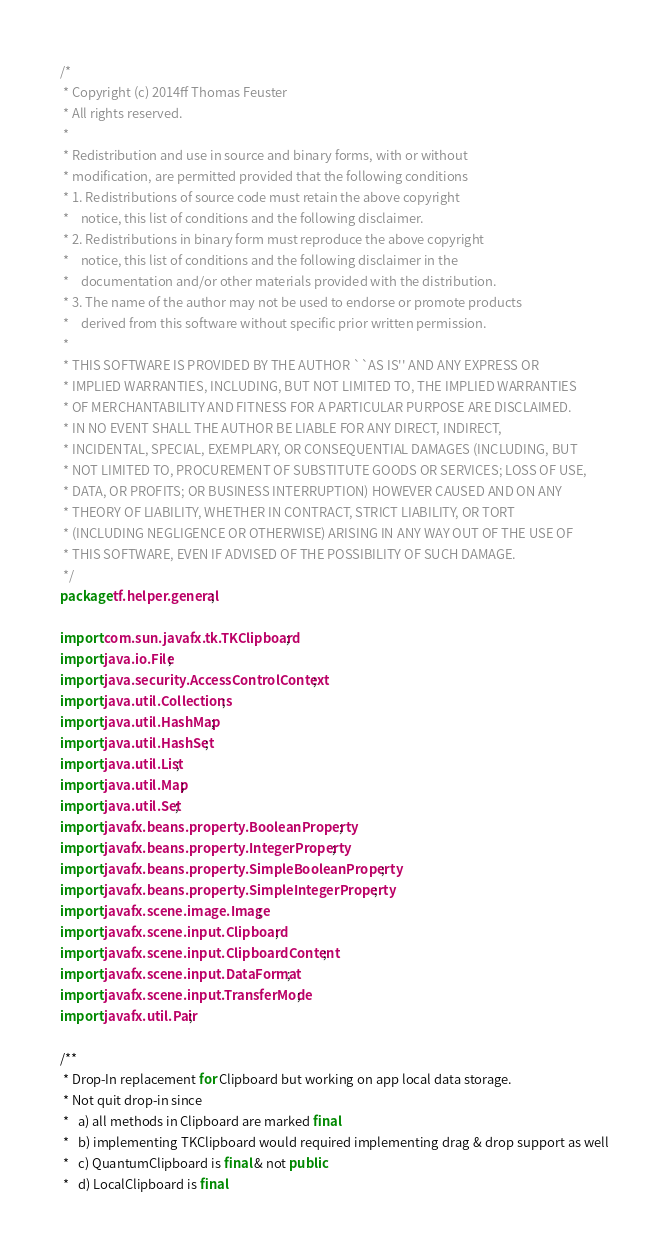Convert code to text. <code><loc_0><loc_0><loc_500><loc_500><_Java_>/*
 * Copyright (c) 2014ff Thomas Feuster
 * All rights reserved.
 * 
 * Redistribution and use in source and binary forms, with or without
 * modification, are permitted provided that the following conditions
 * 1. Redistributions of source code must retain the above copyright
 *    notice, this list of conditions and the following disclaimer.
 * 2. Redistributions in binary form must reproduce the above copyright
 *    notice, this list of conditions and the following disclaimer in the
 *    documentation and/or other materials provided with the distribution.
 * 3. The name of the author may not be used to endorse or promote products
 *    derived from this software without specific prior written permission.
 * 
 * THIS SOFTWARE IS PROVIDED BY THE AUTHOR ``AS IS'' AND ANY EXPRESS OR
 * IMPLIED WARRANTIES, INCLUDING, BUT NOT LIMITED TO, THE IMPLIED WARRANTIES
 * OF MERCHANTABILITY AND FITNESS FOR A PARTICULAR PURPOSE ARE DISCLAIMED.
 * IN NO EVENT SHALL THE AUTHOR BE LIABLE FOR ANY DIRECT, INDIRECT,
 * INCIDENTAL, SPECIAL, EXEMPLARY, OR CONSEQUENTIAL DAMAGES (INCLUDING, BUT
 * NOT LIMITED TO, PROCUREMENT OF SUBSTITUTE GOODS OR SERVICES; LOSS OF USE,
 * DATA, OR PROFITS; OR BUSINESS INTERRUPTION) HOWEVER CAUSED AND ON ANY
 * THEORY OF LIABILITY, WHETHER IN CONTRACT, STRICT LIABILITY, OR TORT
 * (INCLUDING NEGLIGENCE OR OTHERWISE) ARISING IN ANY WAY OUT OF THE USE OF
 * THIS SOFTWARE, EVEN IF ADVISED OF THE POSSIBILITY OF SUCH DAMAGE.
 */
package tf.helper.general;

import com.sun.javafx.tk.TKClipboard;
import java.io.File;
import java.security.AccessControlContext;
import java.util.Collections;
import java.util.HashMap;
import java.util.HashSet;
import java.util.List;
import java.util.Map;
import java.util.Set;
import javafx.beans.property.BooleanProperty;
import javafx.beans.property.IntegerProperty;
import javafx.beans.property.SimpleBooleanProperty;
import javafx.beans.property.SimpleIntegerProperty;
import javafx.scene.image.Image;
import javafx.scene.input.Clipboard;
import javafx.scene.input.ClipboardContent;
import javafx.scene.input.DataFormat;
import javafx.scene.input.TransferMode;
import javafx.util.Pair;

/**
 * Drop-In replacement for Clipboard but working on app local data storage.
 * Not quit drop-in since
 *   a) all methods in Clipboard are marked final
 *   b) implementing TKClipboard would required implementing drag & drop support as well
 *   c) QuantumClipboard is final & not public
 *   d) LocalClipboard is final</code> 